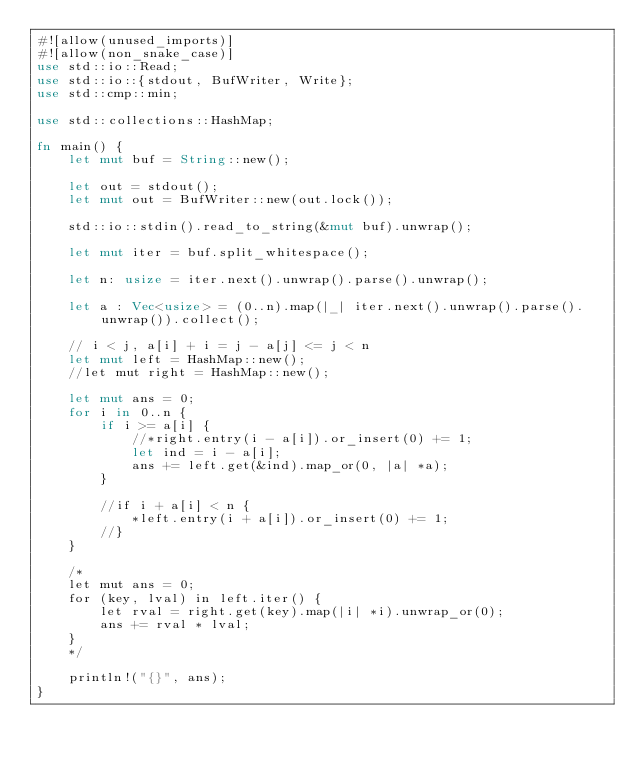Convert code to text. <code><loc_0><loc_0><loc_500><loc_500><_Rust_>#![allow(unused_imports)]
#![allow(non_snake_case)]
use std::io::Read;
use std::io::{stdout, BufWriter, Write};
use std::cmp::min;

use std::collections::HashMap;
 
fn main() {
    let mut buf = String::new();
    
    let out = stdout();
    let mut out = BufWriter::new(out.lock());
 
    std::io::stdin().read_to_string(&mut buf).unwrap();
 
    let mut iter = buf.split_whitespace();
 
    let n: usize = iter.next().unwrap().parse().unwrap();
    
    let a : Vec<usize> = (0..n).map(|_| iter.next().unwrap().parse().unwrap()).collect();
    
    // i < j, a[i] + i = j - a[j] <= j < n
    let mut left = HashMap::new();
    //let mut right = HashMap::new();
    
    let mut ans = 0;
    for i in 0..n {
        if i >= a[i] {
            //*right.entry(i - a[i]).or_insert(0) += 1;
            let ind = i - a[i];
            ans += left.get(&ind).map_or(0, |a| *a);
        }
        
        //if i + a[i] < n {
            *left.entry(i + a[i]).or_insert(0) += 1;
        //}
    }
    
    /*
    let mut ans = 0;
    for (key, lval) in left.iter() {
        let rval = right.get(key).map(|i| *i).unwrap_or(0);
        ans += rval * lval;
    }
    */
    
    println!("{}", ans);
}</code> 